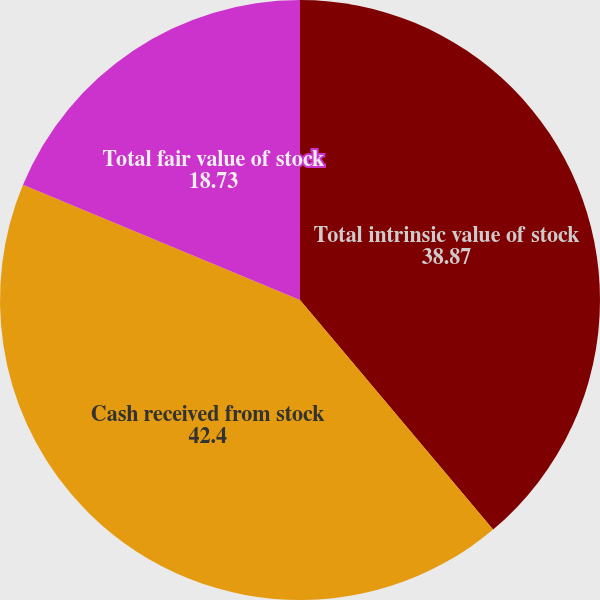Convert chart. <chart><loc_0><loc_0><loc_500><loc_500><pie_chart><fcel>Total intrinsic value of stock<fcel>Cash received from stock<fcel>Total fair value of stock<nl><fcel>38.87%<fcel>42.4%<fcel>18.73%<nl></chart> 